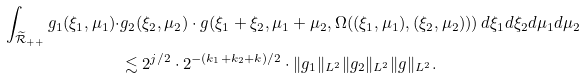<formula> <loc_0><loc_0><loc_500><loc_500>\int _ { \widetilde { \mathcal { R } } _ { + + } } g _ { 1 } ( \xi _ { 1 } , \mu _ { 1 } ) \cdot & g _ { 2 } ( \xi _ { 2 } , \mu _ { 2 } ) \cdot g ( \xi _ { 1 } + \xi _ { 2 } , \mu _ { 1 } + \mu _ { 2 } , \Omega ( ( \xi _ { 1 } , \mu _ { 1 } ) , ( \xi _ { 2 } , \mu _ { 2 } ) ) ) \, d \xi _ { 1 } d \xi _ { 2 } d \mu _ { 1 } d \mu _ { 2 } \\ & \lesssim 2 ^ { j / 2 } \cdot 2 ^ { - ( k _ { 1 } + k _ { 2 } + k ) / 2 } \cdot \| g _ { 1 } \| _ { L ^ { 2 } } \| g _ { 2 } \| _ { L ^ { 2 } } \| g \| _ { L ^ { 2 } } .</formula> 